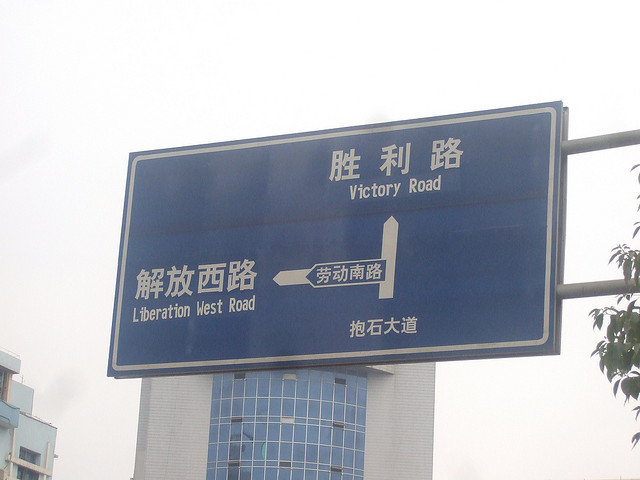Please transcribe the text in this image. ROAD VICTORY Road WEST Liberation 